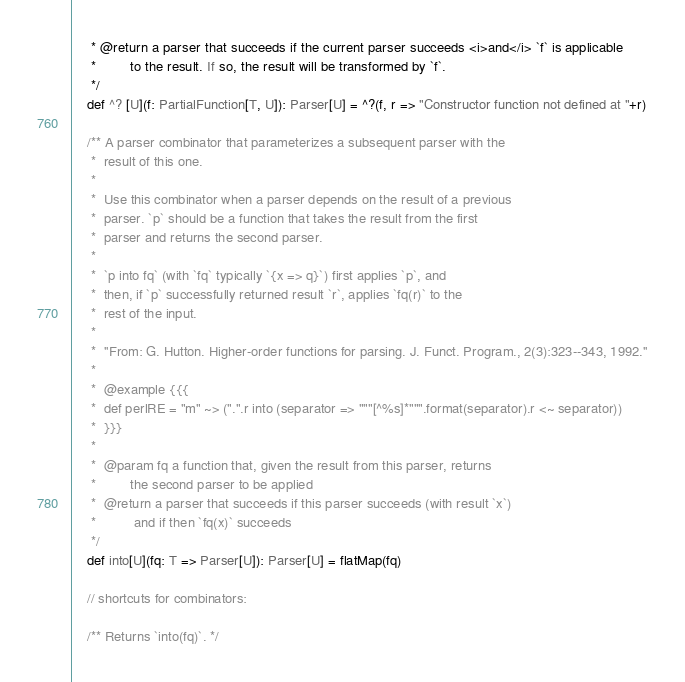<code> <loc_0><loc_0><loc_500><loc_500><_Scala_>     * @return a parser that succeeds if the current parser succeeds <i>and</i> `f` is applicable
     *         to the result. If so, the result will be transformed by `f`.
     */
    def ^? [U](f: PartialFunction[T, U]): Parser[U] = ^?(f, r => "Constructor function not defined at "+r)

    /** A parser combinator that parameterizes a subsequent parser with the
     *  result of this one.
     *
     *  Use this combinator when a parser depends on the result of a previous
     *  parser. `p` should be a function that takes the result from the first
     *  parser and returns the second parser.
     *
     *  `p into fq` (with `fq` typically `{x => q}`) first applies `p`, and
     *  then, if `p` successfully returned result `r`, applies `fq(r)` to the
     *  rest of the input.
     *
     *  ''From: G. Hutton. Higher-order functions for parsing. J. Funct. Program., 2(3):323--343, 1992.''
     *
     *  @example {{{
     *  def perlRE = "m" ~> (".".r into (separator => """[^%s]*""".format(separator).r <~ separator))
     *  }}}
     *
     *  @param fq a function that, given the result from this parser, returns
     *         the second parser to be applied
     *  @return a parser that succeeds if this parser succeeds (with result `x`)
     *          and if then `fq(x)` succeeds
     */
    def into[U](fq: T => Parser[U]): Parser[U] = flatMap(fq)

    // shortcuts for combinators:

    /** Returns `into(fq)`. */</code> 